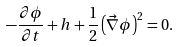Convert formula to latex. <formula><loc_0><loc_0><loc_500><loc_500>- \frac { \partial \phi } { \partial t } + h + \frac { 1 } { 2 } \left ( \vec { \nabla } \phi \right ) ^ { 2 } = 0 .</formula> 